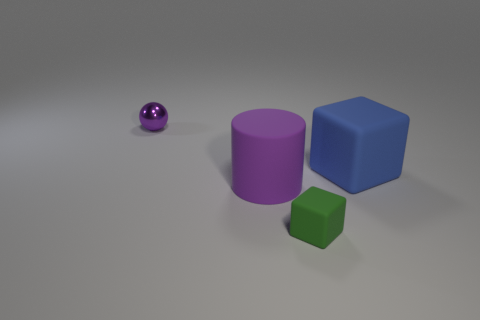What number of things are both in front of the blue rubber block and to the left of the small block?
Give a very brief answer. 1. What is the object to the right of the rubber cube that is on the left side of the large object right of the small green cube made of?
Keep it short and to the point. Rubber. How many other big blocks have the same material as the blue block?
Ensure brevity in your answer.  0. What is the shape of the small thing that is the same color as the large cylinder?
Keep it short and to the point. Sphere. What is the shape of the rubber thing that is the same size as the ball?
Provide a succinct answer. Cube. There is a big cylinder that is the same color as the small metallic sphere; what is it made of?
Ensure brevity in your answer.  Rubber. Are there any tiny green cubes on the right side of the cylinder?
Your answer should be compact. Yes. Is there a blue matte object that has the same shape as the green thing?
Ensure brevity in your answer.  Yes. Is the shape of the small object in front of the metal ball the same as the big rubber object that is to the right of the small green rubber block?
Offer a terse response. Yes. Is there a green matte object that has the same size as the metallic sphere?
Your answer should be compact. Yes. 